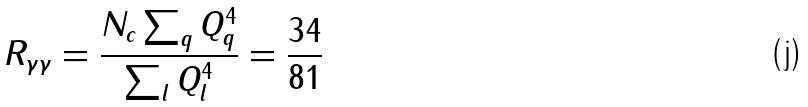<formula> <loc_0><loc_0><loc_500><loc_500>R _ { \gamma \gamma } = \frac { N _ { c } \sum _ { q } Q _ { q } ^ { 4 } } { \sum _ { l } Q _ { l } ^ { 4 } } = \frac { 3 4 } { 8 1 }</formula> 